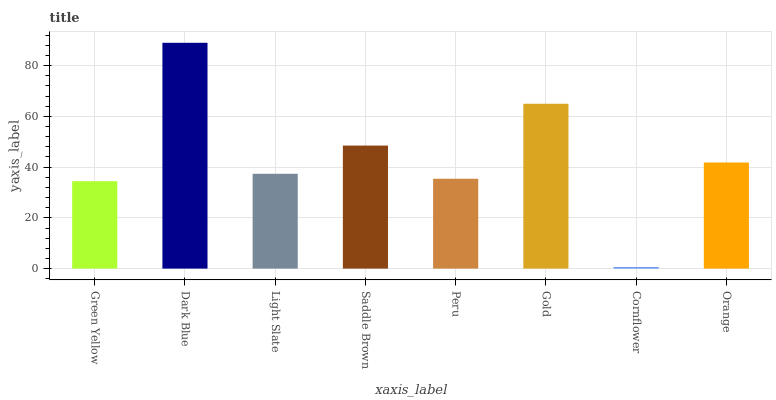Is Light Slate the minimum?
Answer yes or no. No. Is Light Slate the maximum?
Answer yes or no. No. Is Dark Blue greater than Light Slate?
Answer yes or no. Yes. Is Light Slate less than Dark Blue?
Answer yes or no. Yes. Is Light Slate greater than Dark Blue?
Answer yes or no. No. Is Dark Blue less than Light Slate?
Answer yes or no. No. Is Orange the high median?
Answer yes or no. Yes. Is Light Slate the low median?
Answer yes or no. Yes. Is Peru the high median?
Answer yes or no. No. Is Saddle Brown the low median?
Answer yes or no. No. 